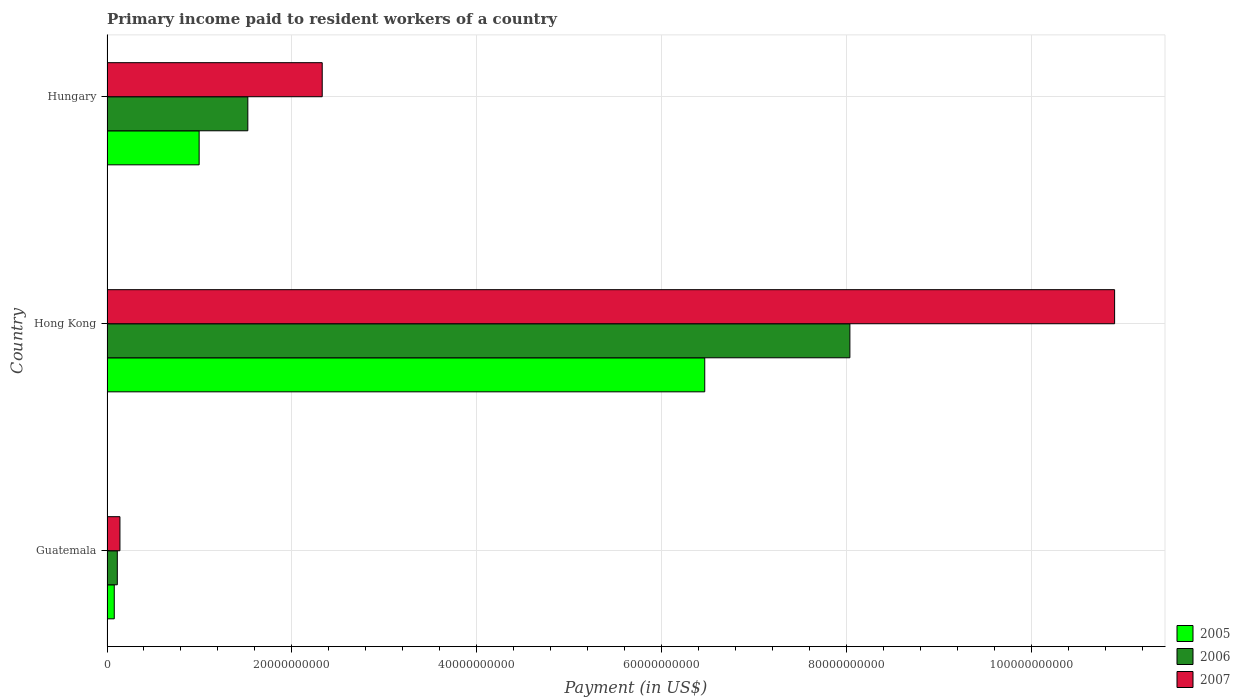How many bars are there on the 2nd tick from the top?
Offer a terse response. 3. How many bars are there on the 2nd tick from the bottom?
Give a very brief answer. 3. What is the label of the 3rd group of bars from the top?
Offer a terse response. Guatemala. What is the amount paid to workers in 2005 in Guatemala?
Offer a very short reply. 7.86e+08. Across all countries, what is the maximum amount paid to workers in 2007?
Your answer should be compact. 1.09e+11. Across all countries, what is the minimum amount paid to workers in 2005?
Your response must be concise. 7.86e+08. In which country was the amount paid to workers in 2005 maximum?
Offer a terse response. Hong Kong. In which country was the amount paid to workers in 2007 minimum?
Make the answer very short. Guatemala. What is the total amount paid to workers in 2006 in the graph?
Give a very brief answer. 9.67e+1. What is the difference between the amount paid to workers in 2007 in Hong Kong and that in Hungary?
Offer a very short reply. 8.57e+1. What is the difference between the amount paid to workers in 2005 in Hong Kong and the amount paid to workers in 2006 in Hungary?
Keep it short and to the point. 4.94e+1. What is the average amount paid to workers in 2007 per country?
Keep it short and to the point. 4.46e+1. What is the difference between the amount paid to workers in 2007 and amount paid to workers in 2005 in Guatemala?
Give a very brief answer. 6.12e+08. What is the ratio of the amount paid to workers in 2007 in Hong Kong to that in Hungary?
Offer a terse response. 4.68. Is the amount paid to workers in 2007 in Guatemala less than that in Hungary?
Offer a very short reply. Yes. Is the difference between the amount paid to workers in 2007 in Hong Kong and Hungary greater than the difference between the amount paid to workers in 2005 in Hong Kong and Hungary?
Keep it short and to the point. Yes. What is the difference between the highest and the second highest amount paid to workers in 2007?
Offer a very short reply. 8.57e+1. What is the difference between the highest and the lowest amount paid to workers in 2005?
Your response must be concise. 6.39e+1. Is the sum of the amount paid to workers in 2006 in Guatemala and Hong Kong greater than the maximum amount paid to workers in 2007 across all countries?
Your answer should be compact. No. What does the 1st bar from the top in Hong Kong represents?
Offer a very short reply. 2007. What does the 3rd bar from the bottom in Hong Kong represents?
Offer a very short reply. 2007. Is it the case that in every country, the sum of the amount paid to workers in 2005 and amount paid to workers in 2006 is greater than the amount paid to workers in 2007?
Keep it short and to the point. Yes. Are all the bars in the graph horizontal?
Keep it short and to the point. Yes. Does the graph contain any zero values?
Give a very brief answer. No. Where does the legend appear in the graph?
Ensure brevity in your answer.  Bottom right. What is the title of the graph?
Provide a short and direct response. Primary income paid to resident workers of a country. What is the label or title of the X-axis?
Give a very brief answer. Payment (in US$). What is the label or title of the Y-axis?
Provide a short and direct response. Country. What is the Payment (in US$) in 2005 in Guatemala?
Provide a succinct answer. 7.86e+08. What is the Payment (in US$) in 2006 in Guatemala?
Provide a succinct answer. 1.12e+09. What is the Payment (in US$) in 2007 in Guatemala?
Offer a very short reply. 1.40e+09. What is the Payment (in US$) of 2005 in Hong Kong?
Give a very brief answer. 6.47e+1. What is the Payment (in US$) of 2006 in Hong Kong?
Your response must be concise. 8.04e+1. What is the Payment (in US$) of 2007 in Hong Kong?
Offer a very short reply. 1.09e+11. What is the Payment (in US$) of 2005 in Hungary?
Offer a terse response. 9.97e+09. What is the Payment (in US$) of 2006 in Hungary?
Provide a short and direct response. 1.52e+1. What is the Payment (in US$) in 2007 in Hungary?
Make the answer very short. 2.33e+1. Across all countries, what is the maximum Payment (in US$) of 2005?
Provide a succinct answer. 6.47e+1. Across all countries, what is the maximum Payment (in US$) in 2006?
Your response must be concise. 8.04e+1. Across all countries, what is the maximum Payment (in US$) in 2007?
Offer a terse response. 1.09e+11. Across all countries, what is the minimum Payment (in US$) of 2005?
Give a very brief answer. 7.86e+08. Across all countries, what is the minimum Payment (in US$) in 2006?
Your answer should be very brief. 1.12e+09. Across all countries, what is the minimum Payment (in US$) in 2007?
Your response must be concise. 1.40e+09. What is the total Payment (in US$) in 2005 in the graph?
Ensure brevity in your answer.  7.54e+1. What is the total Payment (in US$) of 2006 in the graph?
Give a very brief answer. 9.67e+1. What is the total Payment (in US$) of 2007 in the graph?
Make the answer very short. 1.34e+11. What is the difference between the Payment (in US$) of 2005 in Guatemala and that in Hong Kong?
Offer a very short reply. -6.39e+1. What is the difference between the Payment (in US$) of 2006 in Guatemala and that in Hong Kong?
Ensure brevity in your answer.  -7.93e+1. What is the difference between the Payment (in US$) of 2007 in Guatemala and that in Hong Kong?
Keep it short and to the point. -1.08e+11. What is the difference between the Payment (in US$) of 2005 in Guatemala and that in Hungary?
Give a very brief answer. -9.18e+09. What is the difference between the Payment (in US$) in 2006 in Guatemala and that in Hungary?
Make the answer very short. -1.41e+1. What is the difference between the Payment (in US$) of 2007 in Guatemala and that in Hungary?
Offer a very short reply. -2.19e+1. What is the difference between the Payment (in US$) of 2005 in Hong Kong and that in Hungary?
Offer a terse response. 5.47e+1. What is the difference between the Payment (in US$) of 2006 in Hong Kong and that in Hungary?
Give a very brief answer. 6.51e+1. What is the difference between the Payment (in US$) of 2007 in Hong Kong and that in Hungary?
Your response must be concise. 8.57e+1. What is the difference between the Payment (in US$) of 2005 in Guatemala and the Payment (in US$) of 2006 in Hong Kong?
Your response must be concise. -7.96e+1. What is the difference between the Payment (in US$) of 2005 in Guatemala and the Payment (in US$) of 2007 in Hong Kong?
Offer a terse response. -1.08e+11. What is the difference between the Payment (in US$) in 2006 in Guatemala and the Payment (in US$) in 2007 in Hong Kong?
Give a very brief answer. -1.08e+11. What is the difference between the Payment (in US$) of 2005 in Guatemala and the Payment (in US$) of 2006 in Hungary?
Offer a very short reply. -1.45e+1. What is the difference between the Payment (in US$) in 2005 in Guatemala and the Payment (in US$) in 2007 in Hungary?
Offer a terse response. -2.25e+1. What is the difference between the Payment (in US$) in 2006 in Guatemala and the Payment (in US$) in 2007 in Hungary?
Ensure brevity in your answer.  -2.22e+1. What is the difference between the Payment (in US$) of 2005 in Hong Kong and the Payment (in US$) of 2006 in Hungary?
Offer a terse response. 4.94e+1. What is the difference between the Payment (in US$) of 2005 in Hong Kong and the Payment (in US$) of 2007 in Hungary?
Your answer should be very brief. 4.14e+1. What is the difference between the Payment (in US$) in 2006 in Hong Kong and the Payment (in US$) in 2007 in Hungary?
Your answer should be compact. 5.71e+1. What is the average Payment (in US$) in 2005 per country?
Make the answer very short. 2.51e+1. What is the average Payment (in US$) in 2006 per country?
Keep it short and to the point. 3.22e+1. What is the average Payment (in US$) of 2007 per country?
Keep it short and to the point. 4.46e+1. What is the difference between the Payment (in US$) of 2005 and Payment (in US$) of 2006 in Guatemala?
Your answer should be very brief. -3.28e+08. What is the difference between the Payment (in US$) of 2005 and Payment (in US$) of 2007 in Guatemala?
Your answer should be compact. -6.12e+08. What is the difference between the Payment (in US$) of 2006 and Payment (in US$) of 2007 in Guatemala?
Ensure brevity in your answer.  -2.84e+08. What is the difference between the Payment (in US$) of 2005 and Payment (in US$) of 2006 in Hong Kong?
Offer a very short reply. -1.57e+1. What is the difference between the Payment (in US$) in 2005 and Payment (in US$) in 2007 in Hong Kong?
Provide a short and direct response. -4.43e+1. What is the difference between the Payment (in US$) in 2006 and Payment (in US$) in 2007 in Hong Kong?
Your answer should be compact. -2.86e+1. What is the difference between the Payment (in US$) of 2005 and Payment (in US$) of 2006 in Hungary?
Provide a succinct answer. -5.27e+09. What is the difference between the Payment (in US$) in 2005 and Payment (in US$) in 2007 in Hungary?
Provide a succinct answer. -1.33e+1. What is the difference between the Payment (in US$) of 2006 and Payment (in US$) of 2007 in Hungary?
Provide a succinct answer. -8.05e+09. What is the ratio of the Payment (in US$) of 2005 in Guatemala to that in Hong Kong?
Your answer should be very brief. 0.01. What is the ratio of the Payment (in US$) of 2006 in Guatemala to that in Hong Kong?
Provide a short and direct response. 0.01. What is the ratio of the Payment (in US$) of 2007 in Guatemala to that in Hong Kong?
Ensure brevity in your answer.  0.01. What is the ratio of the Payment (in US$) of 2005 in Guatemala to that in Hungary?
Keep it short and to the point. 0.08. What is the ratio of the Payment (in US$) in 2006 in Guatemala to that in Hungary?
Keep it short and to the point. 0.07. What is the ratio of the Payment (in US$) in 2007 in Guatemala to that in Hungary?
Your answer should be very brief. 0.06. What is the ratio of the Payment (in US$) of 2005 in Hong Kong to that in Hungary?
Make the answer very short. 6.49. What is the ratio of the Payment (in US$) in 2006 in Hong Kong to that in Hungary?
Ensure brevity in your answer.  5.28. What is the ratio of the Payment (in US$) in 2007 in Hong Kong to that in Hungary?
Your answer should be compact. 4.68. What is the difference between the highest and the second highest Payment (in US$) of 2005?
Ensure brevity in your answer.  5.47e+1. What is the difference between the highest and the second highest Payment (in US$) of 2006?
Ensure brevity in your answer.  6.51e+1. What is the difference between the highest and the second highest Payment (in US$) in 2007?
Give a very brief answer. 8.57e+1. What is the difference between the highest and the lowest Payment (in US$) in 2005?
Offer a terse response. 6.39e+1. What is the difference between the highest and the lowest Payment (in US$) in 2006?
Provide a succinct answer. 7.93e+1. What is the difference between the highest and the lowest Payment (in US$) of 2007?
Make the answer very short. 1.08e+11. 